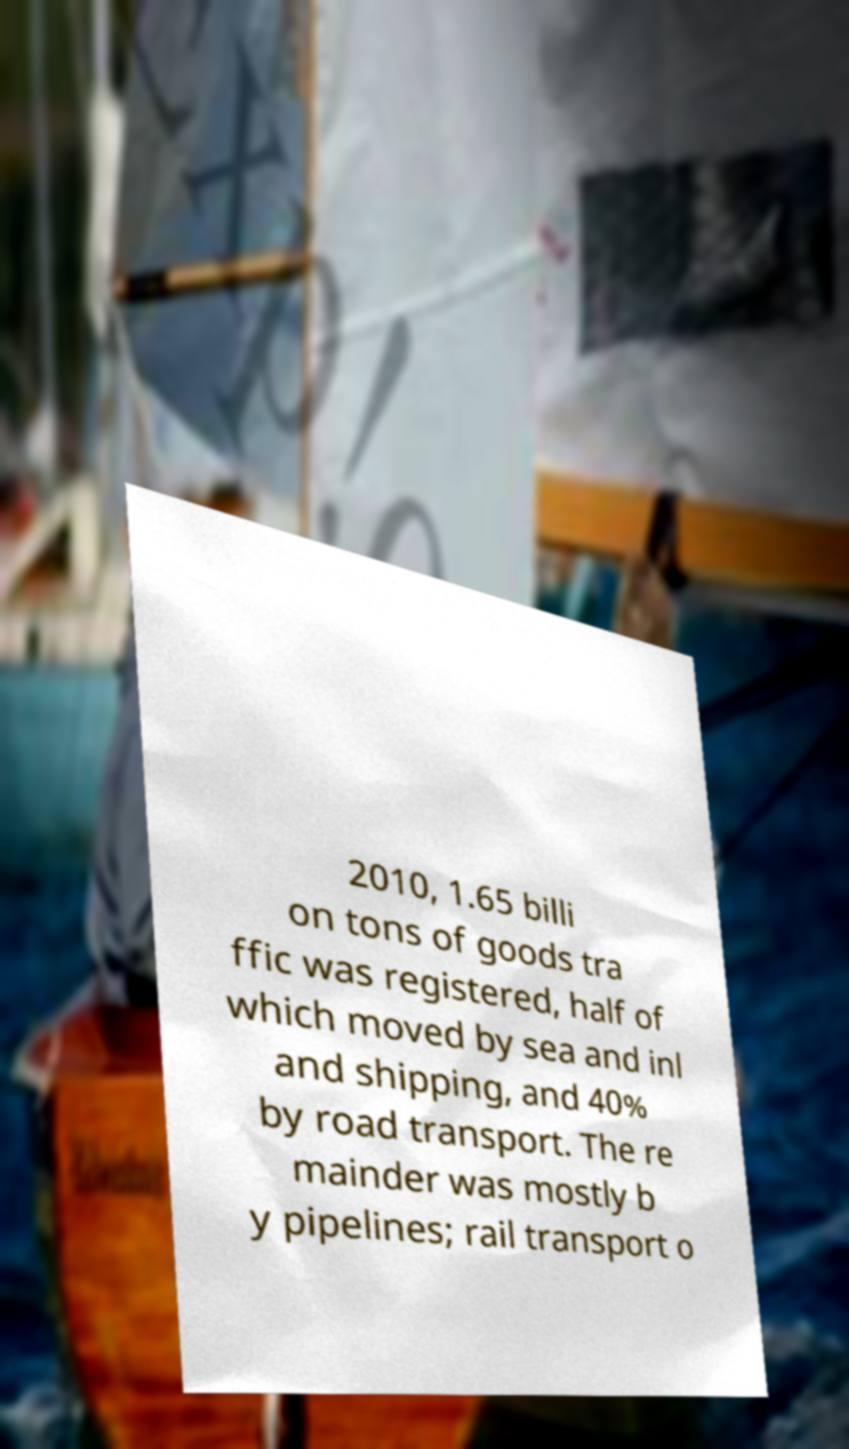For documentation purposes, I need the text within this image transcribed. Could you provide that? 2010, 1.65 billi on tons of goods tra ffic was registered, half of which moved by sea and inl and shipping, and 40% by road transport. The re mainder was mostly b y pipelines; rail transport o 